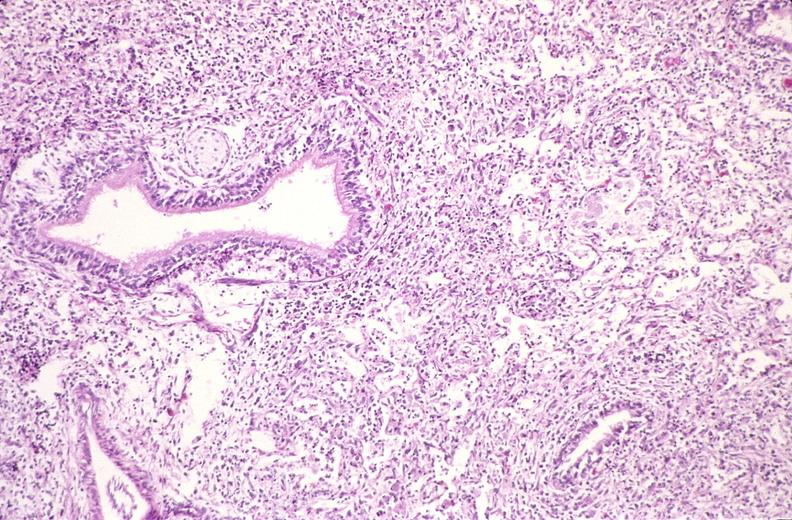does this image show lung, histoplasma pneumonia?
Answer the question using a single word or phrase. Yes 